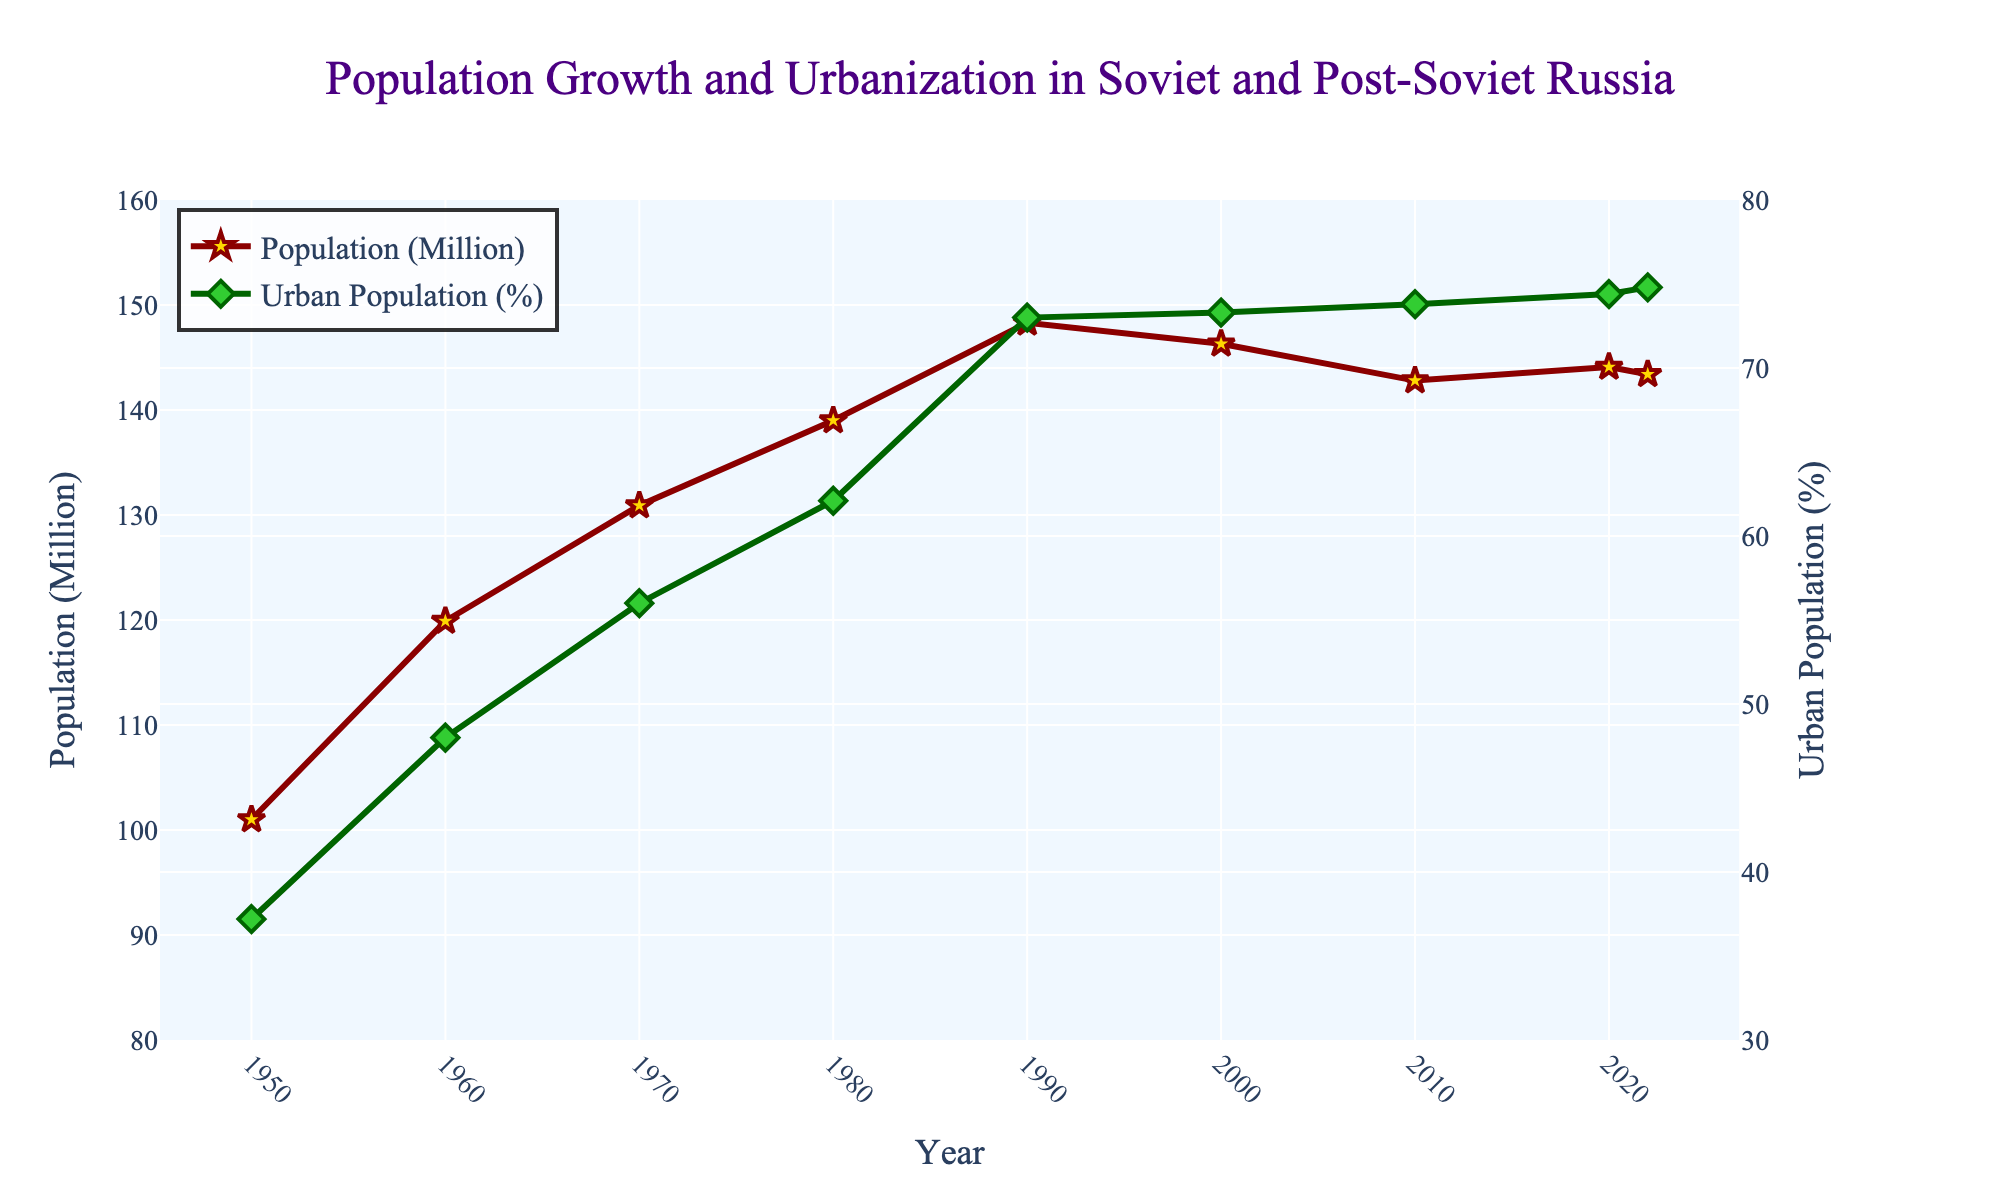What is the title of the figure? The title is displayed at the top center of the figure. It is written in a larger font and is easier to identify.
Answer: Population Growth and Urbanization in Soviet and Post-Soviet Russia How many data points are there for population in the figure? The population data points correspond to the number of years listed on the x-axis. There are visible data markers for each listed year.
Answer: 9 What is the urban population percentage in 1960? Locate the data point on the second line (green) for the year 1960, and read the value associated with it.
Answer: 48.0% By how many millions did the population increase from 1950 to 1980? Find the population values for 1950 and 1980 on the red line. Compute the difference: 139.0 million (1980) - 101.0 million (1950).
Answer: 38.0 million Which year showed the highest urban population percentage? Identify the peak value along the green line representing the urban population percentage. The x-axis value corresponding to this peak will be the year.
Answer: 2022 What was the difference in urban population percentage between 1980 and 1990? Get the values for 1980 and 1990 from the green line and calculate the difference: 73.0% (1990) - 62.1% (1980).
Answer: 10.9% Compare the population in 1990 and 2000. Did it increase or decrease, and by how much? Check the population values for 1990 and 2000 on the red line. Calculate the difference and note if it is positive (increase) or negative (decrease): 148.3 million (1990) - 146.3 million (2000).
Answer: Decrease by 2.0 million What is the overall trend of the urban population percentage from 1950 to 2022? Observe the overall direction of the green line over time.
Answer: Increasing Which year marks the first time the population dropped below 145 million after 1990? Look for the first data point on the red line after 1990 where the population is below 145 million.
Answer: 2010 